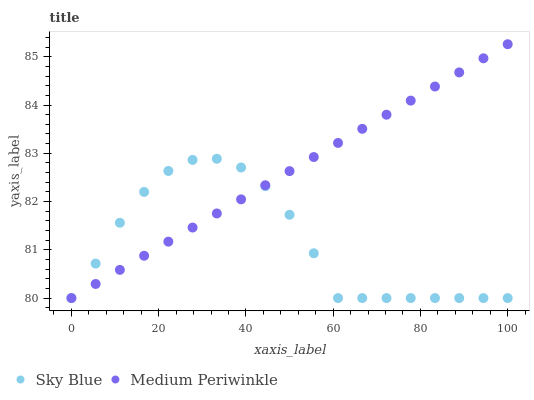Does Sky Blue have the minimum area under the curve?
Answer yes or no. Yes. Does Medium Periwinkle have the maximum area under the curve?
Answer yes or no. Yes. Does Medium Periwinkle have the minimum area under the curve?
Answer yes or no. No. Is Medium Periwinkle the smoothest?
Answer yes or no. Yes. Is Sky Blue the roughest?
Answer yes or no. Yes. Is Medium Periwinkle the roughest?
Answer yes or no. No. Does Sky Blue have the lowest value?
Answer yes or no. Yes. Does Medium Periwinkle have the highest value?
Answer yes or no. Yes. Does Sky Blue intersect Medium Periwinkle?
Answer yes or no. Yes. Is Sky Blue less than Medium Periwinkle?
Answer yes or no. No. Is Sky Blue greater than Medium Periwinkle?
Answer yes or no. No. 